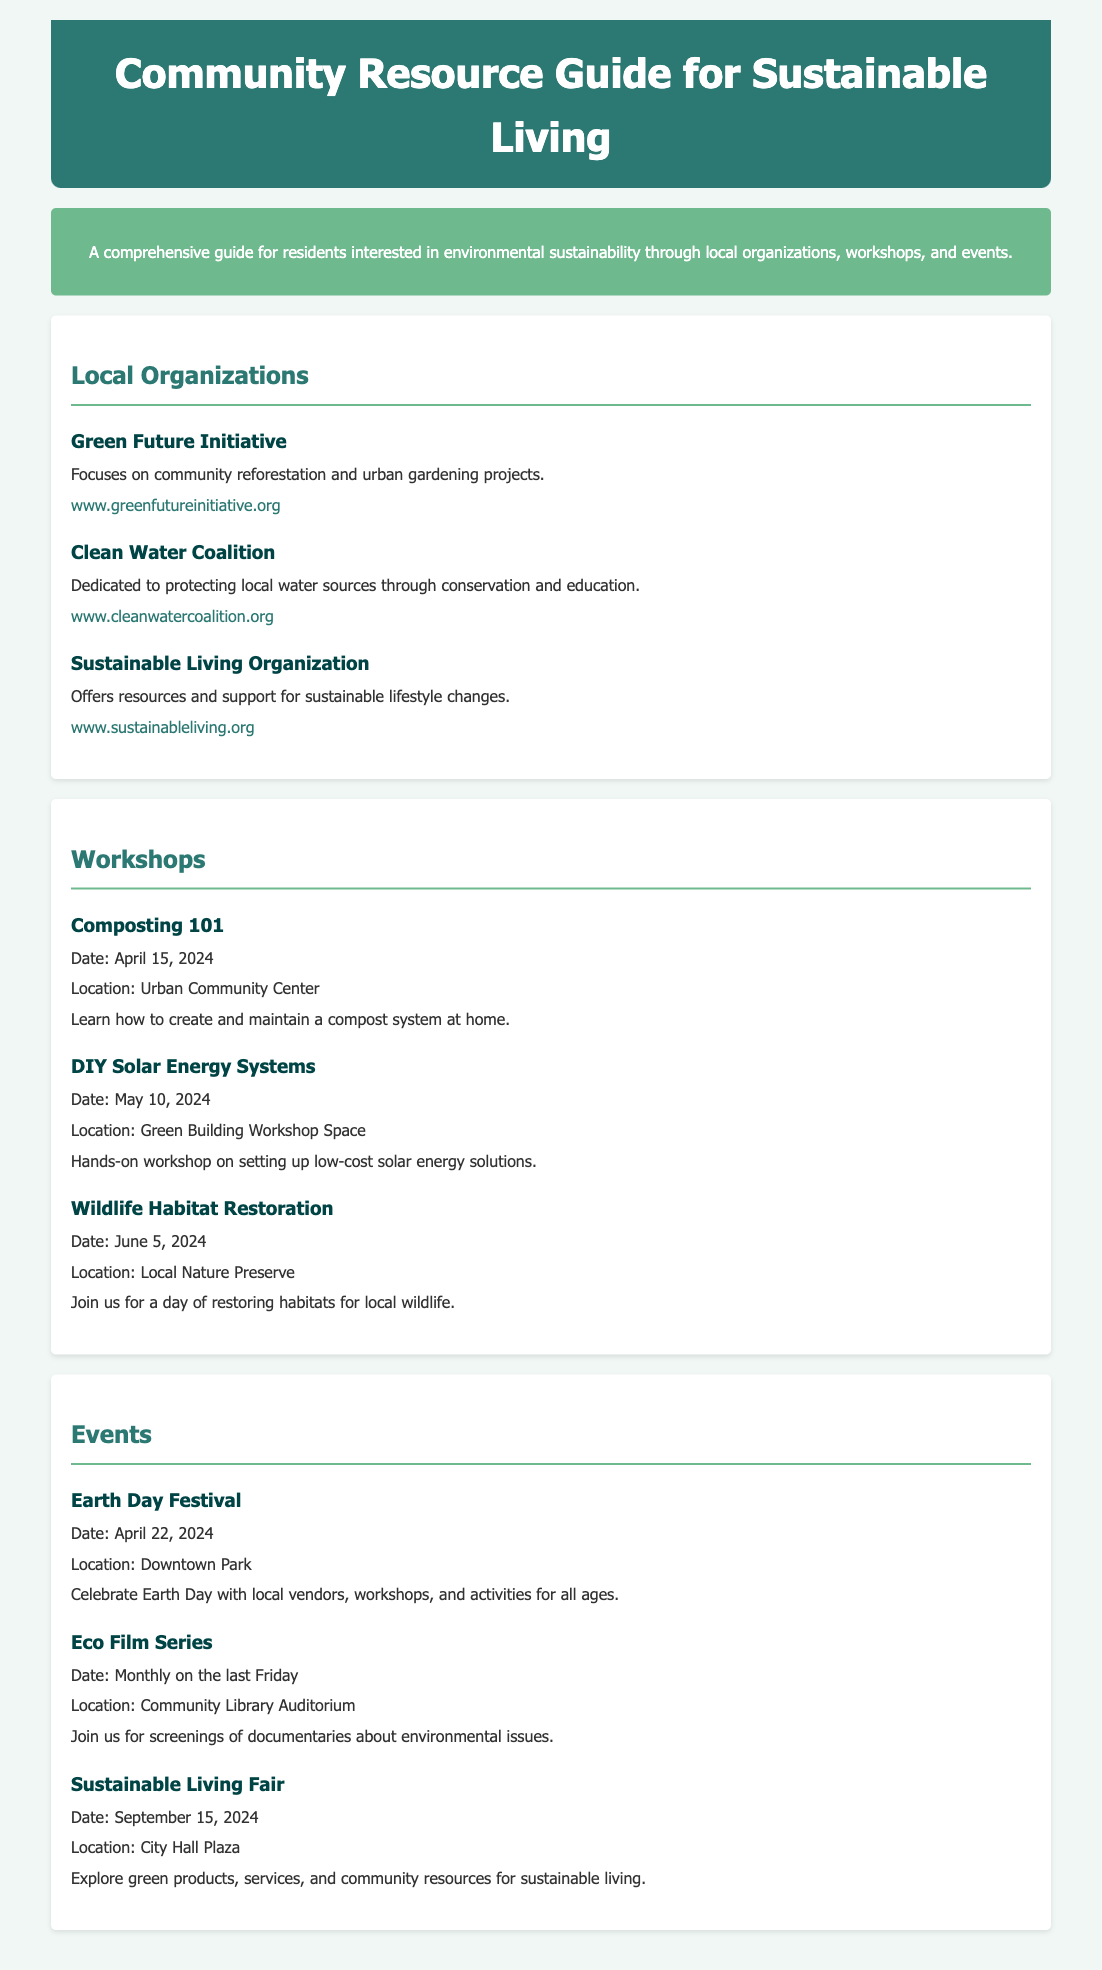What is the name of the workshop on composting? The workshop on composting is titled "Composting 101."
Answer: Composting 101 When is the Earth Day Festival taking place? The Earth Day Festival is scheduled for April 22, 2024.
Answer: April 22, 2024 What organization focuses on reforestation? The organization that focuses on reforestation is the "Green Future Initiative."
Answer: Green Future Initiative Where is the Wildlife Habitat Restoration workshop held? The Wildlife Habitat Restoration workshop is held at the "Local Nature Preserve."
Answer: Local Nature Preserve How often is the Eco Film Series held? The Eco Film Series is held monthly on the last Friday.
Answer: Monthly on the last Friday Which organization's focus is on local water source protection? The organization focused on local water source protection is the "Clean Water Coalition."
Answer: Clean Water Coalition What date is the DIY Solar Energy Systems workshop? The DIY Solar Energy Systems workshop is on May 10, 2024.
Answer: May 10, 2024 What event celebrates Earth Day? The event that celebrates Earth Day is the "Earth Day Festival."
Answer: Earth Day Festival What color is the background of the document? The background color of the document is a soft greenish tone.
Answer: #f0f7f4 